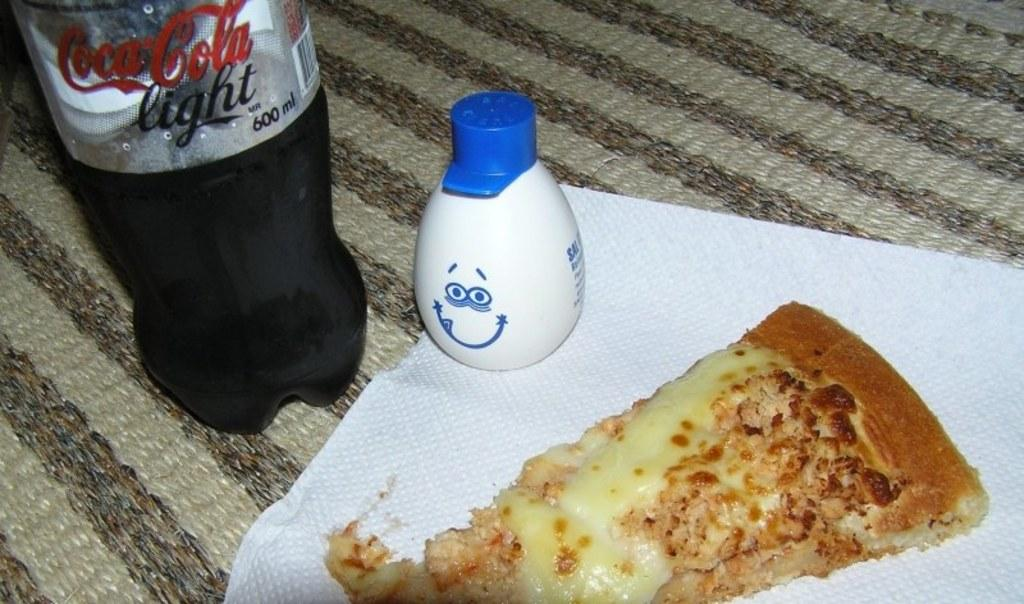What object is located in the right bottom of the image? There is a tissue paper in the right bottom of the image. What is placed on the tissue paper? There is a food item placed on the tissue paper. How many bottles are visible in the image? There are two bottles visible in the image. Where are the bottles located in the image? The bottles are located at the top of the image. What type of shirt is being discovered in the image? There is no shirt being discovered in the image; the focus is on the tissue paper, food item, and bottles. 